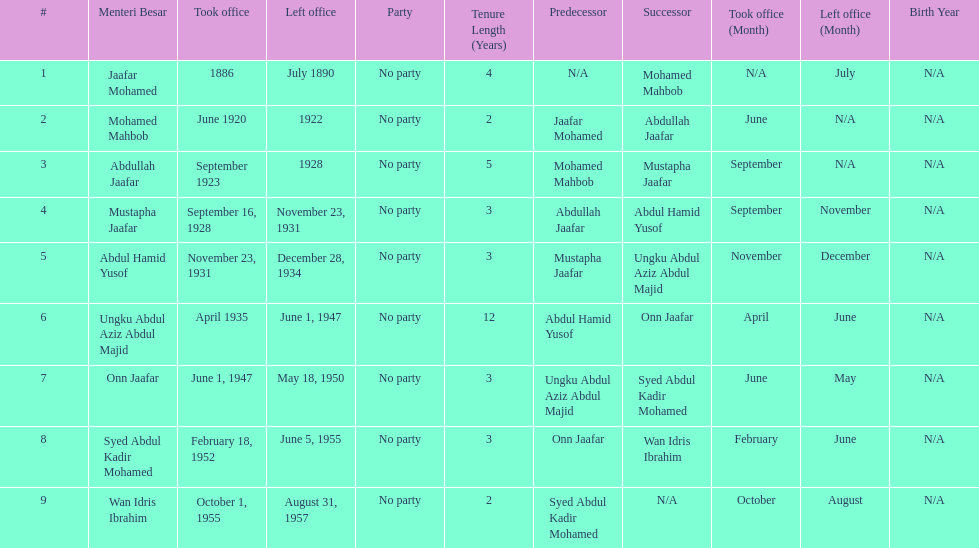Who took office after onn jaafar? Syed Abdul Kadir Mohamed. 